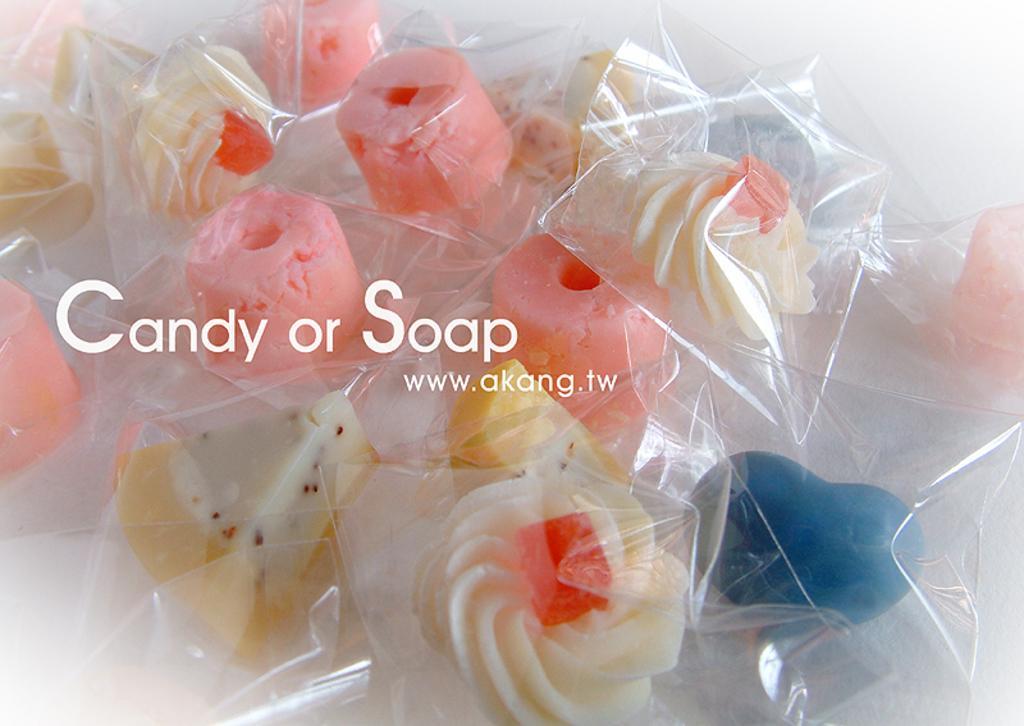Could you give a brief overview of what you see in this image? In this picture we can see candies in packets, some text and in the background we can see white color. 